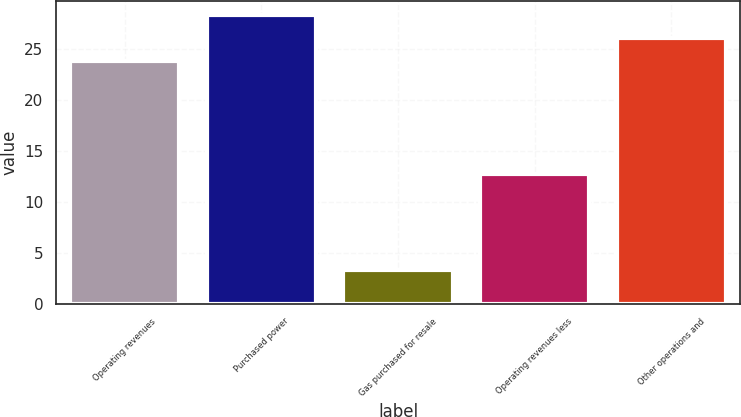<chart> <loc_0><loc_0><loc_500><loc_500><bar_chart><fcel>Operating revenues<fcel>Purchased power<fcel>Gas purchased for resale<fcel>Operating revenues less<fcel>Other operations and<nl><fcel>23.9<fcel>28.34<fcel>3.3<fcel>12.7<fcel>26.12<nl></chart> 